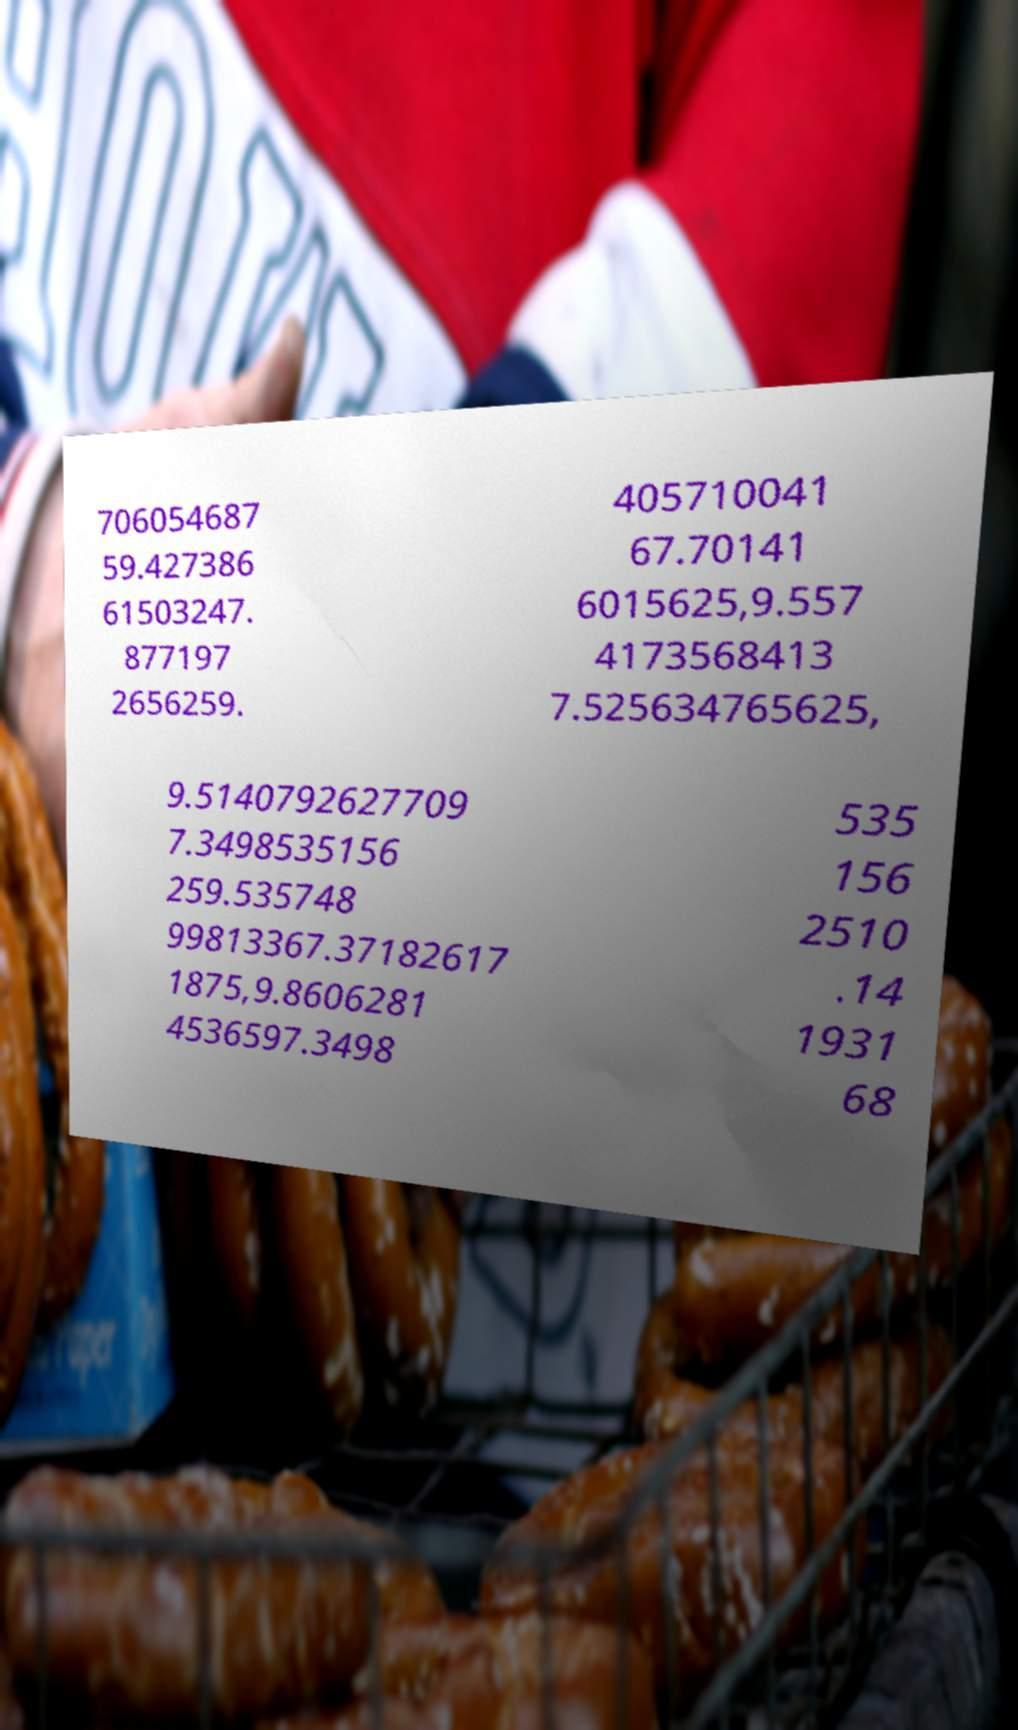I need the written content from this picture converted into text. Can you do that? 706054687 59.427386 61503247. 877197 2656259. 405710041 67.70141 6015625,9.557 4173568413 7.525634765625, 9.5140792627709 7.3498535156 259.535748 99813367.37182617 1875,9.8606281 4536597.3498 535 156 2510 .14 1931 68 